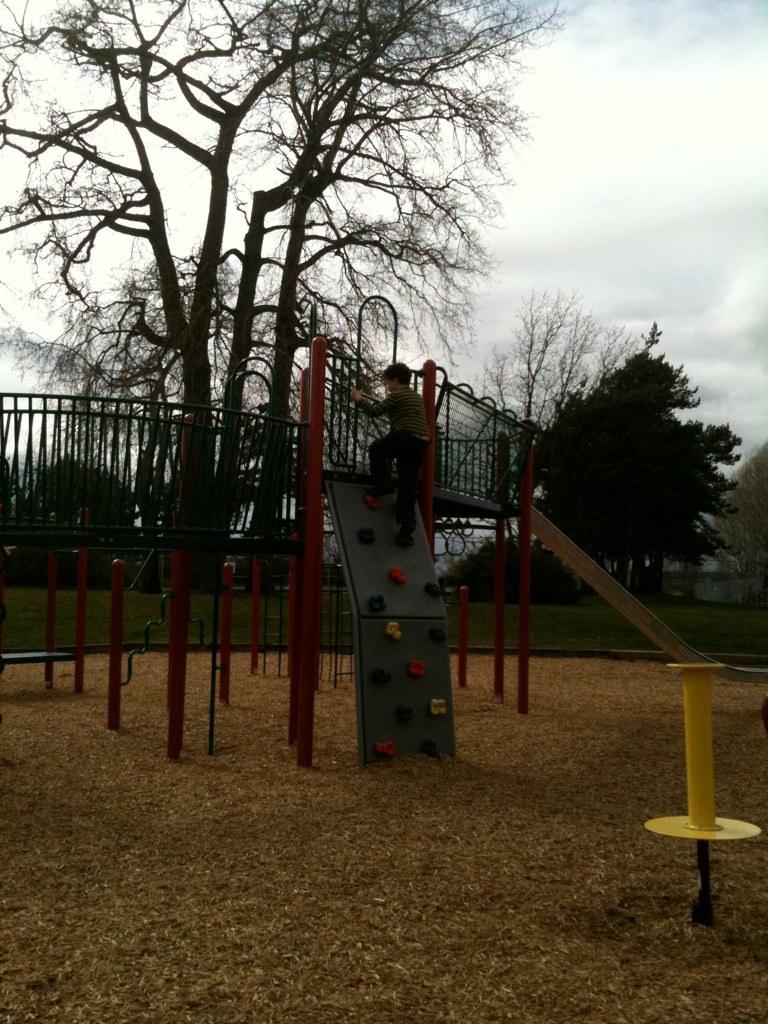What type of structure is visible in the image? There is a grille in the image. What are the rods used for in the image? The purpose of the rods is not specified in the image. Who is present in the image? There is a boy in the image. What type of vegetation can be seen in the image? There are trees and grass in the image. What is the weather like in the image? The sky is cloudy in the image. Can you describe any other objects in the image? There are unspecified objects in the image. How many dogs are playing with the boy in the image? There are no dogs present in the image. What date is marked on the calendar in the image? There is no calendar present in the image. 